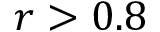Convert formula to latex. <formula><loc_0><loc_0><loc_500><loc_500>r > 0 . 8</formula> 